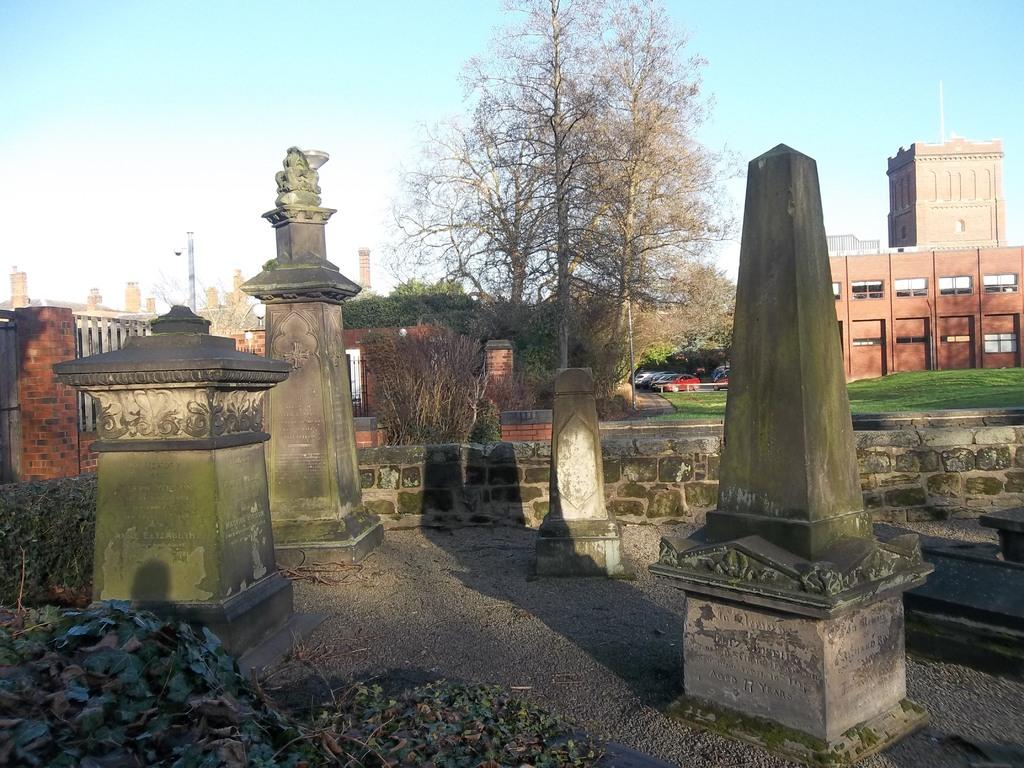What is located in the middle of the picture? There are four memorials in the middle of the picture. What can be seen in the background of the picture? There are trees and at least one building in the background of the picture. What is visible in the sky in the background of the picture? The sky is visible in the background of the picture. What type of stick can be seen playing in harmony with the memorials in the image? There is no stick or any indication of harmony present in the image. 